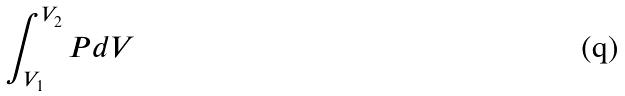Convert formula to latex. <formula><loc_0><loc_0><loc_500><loc_500>\int _ { V _ { 1 } } ^ { V _ { 2 } } P d V</formula> 